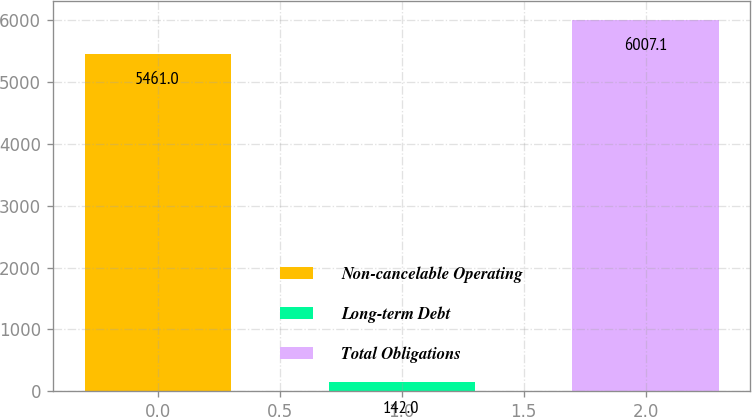Convert chart to OTSL. <chart><loc_0><loc_0><loc_500><loc_500><bar_chart><fcel>Non-cancelable Operating<fcel>Long-term Debt<fcel>Total Obligations<nl><fcel>5461<fcel>142<fcel>6007.1<nl></chart> 